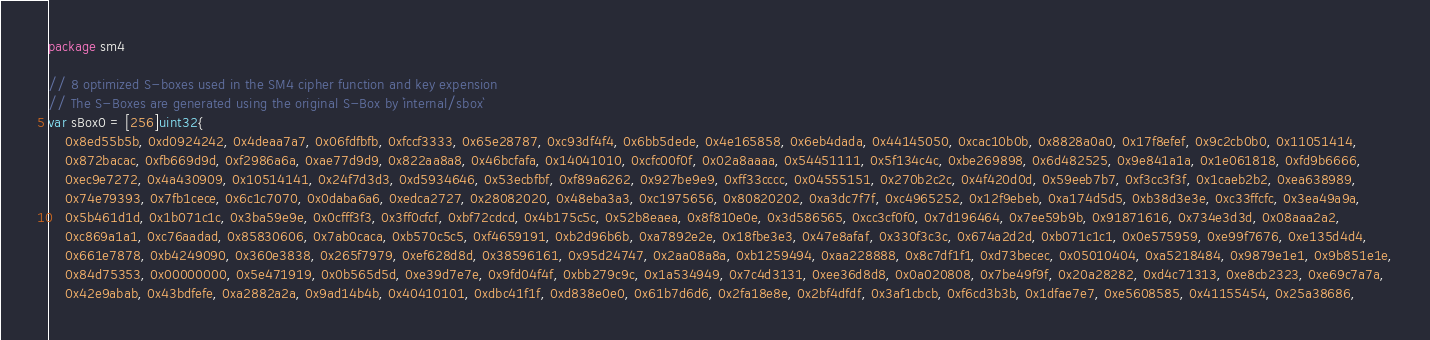<code> <loc_0><loc_0><loc_500><loc_500><_Go_>package sm4

// 8 optimized S-boxes used in the SM4 cipher function and key expension
// The S-Boxes are generated using the original S-Box by `internal/sbox`
var sBox0 = [256]uint32{
	0x8ed55b5b, 0xd0924242, 0x4deaa7a7, 0x06fdfbfb, 0xfccf3333, 0x65e28787, 0xc93df4f4, 0x6bb5dede, 0x4e165858, 0x6eb4dada, 0x44145050, 0xcac10b0b, 0x8828a0a0, 0x17f8efef, 0x9c2cb0b0, 0x11051414,
	0x872bacac, 0xfb669d9d, 0xf2986a6a, 0xae77d9d9, 0x822aa8a8, 0x46bcfafa, 0x14041010, 0xcfc00f0f, 0x02a8aaaa, 0x54451111, 0x5f134c4c, 0xbe269898, 0x6d482525, 0x9e841a1a, 0x1e061818, 0xfd9b6666,
	0xec9e7272, 0x4a430909, 0x10514141, 0x24f7d3d3, 0xd5934646, 0x53ecbfbf, 0xf89a6262, 0x927be9e9, 0xff33cccc, 0x04555151, 0x270b2c2c, 0x4f420d0d, 0x59eeb7b7, 0xf3cc3f3f, 0x1caeb2b2, 0xea638989,
	0x74e79393, 0x7fb1cece, 0x6c1c7070, 0x0daba6a6, 0xedca2727, 0x28082020, 0x48eba3a3, 0xc1975656, 0x80820202, 0xa3dc7f7f, 0xc4965252, 0x12f9ebeb, 0xa174d5d5, 0xb38d3e3e, 0xc33ffcfc, 0x3ea49a9a,
	0x5b461d1d, 0x1b071c1c, 0x3ba59e9e, 0x0cfff3f3, 0x3ff0cfcf, 0xbf72cdcd, 0x4b175c5c, 0x52b8eaea, 0x8f810e0e, 0x3d586565, 0xcc3cf0f0, 0x7d196464, 0x7ee59b9b, 0x91871616, 0x734e3d3d, 0x08aaa2a2,
	0xc869a1a1, 0xc76aadad, 0x85830606, 0x7ab0caca, 0xb570c5c5, 0xf4659191, 0xb2d96b6b, 0xa7892e2e, 0x18fbe3e3, 0x47e8afaf, 0x330f3c3c, 0x674a2d2d, 0xb071c1c1, 0x0e575959, 0xe99f7676, 0xe135d4d4,
	0x661e7878, 0xb4249090, 0x360e3838, 0x265f7979, 0xef628d8d, 0x38596161, 0x95d24747, 0x2aa08a8a, 0xb1259494, 0xaa228888, 0x8c7df1f1, 0xd73becec, 0x05010404, 0xa5218484, 0x9879e1e1, 0x9b851e1e,
	0x84d75353, 0x00000000, 0x5e471919, 0x0b565d5d, 0xe39d7e7e, 0x9fd04f4f, 0xbb279c9c, 0x1a534949, 0x7c4d3131, 0xee36d8d8, 0x0a020808, 0x7be49f9f, 0x20a28282, 0xd4c71313, 0xe8cb2323, 0xe69c7a7a,
	0x42e9abab, 0x43bdfefe, 0xa2882a2a, 0x9ad14b4b, 0x40410101, 0xdbc41f1f, 0xd838e0e0, 0x61b7d6d6, 0x2fa18e8e, 0x2bf4dfdf, 0x3af1cbcb, 0xf6cd3b3b, 0x1dfae7e7, 0xe5608585, 0x41155454, 0x25a38686,</code> 